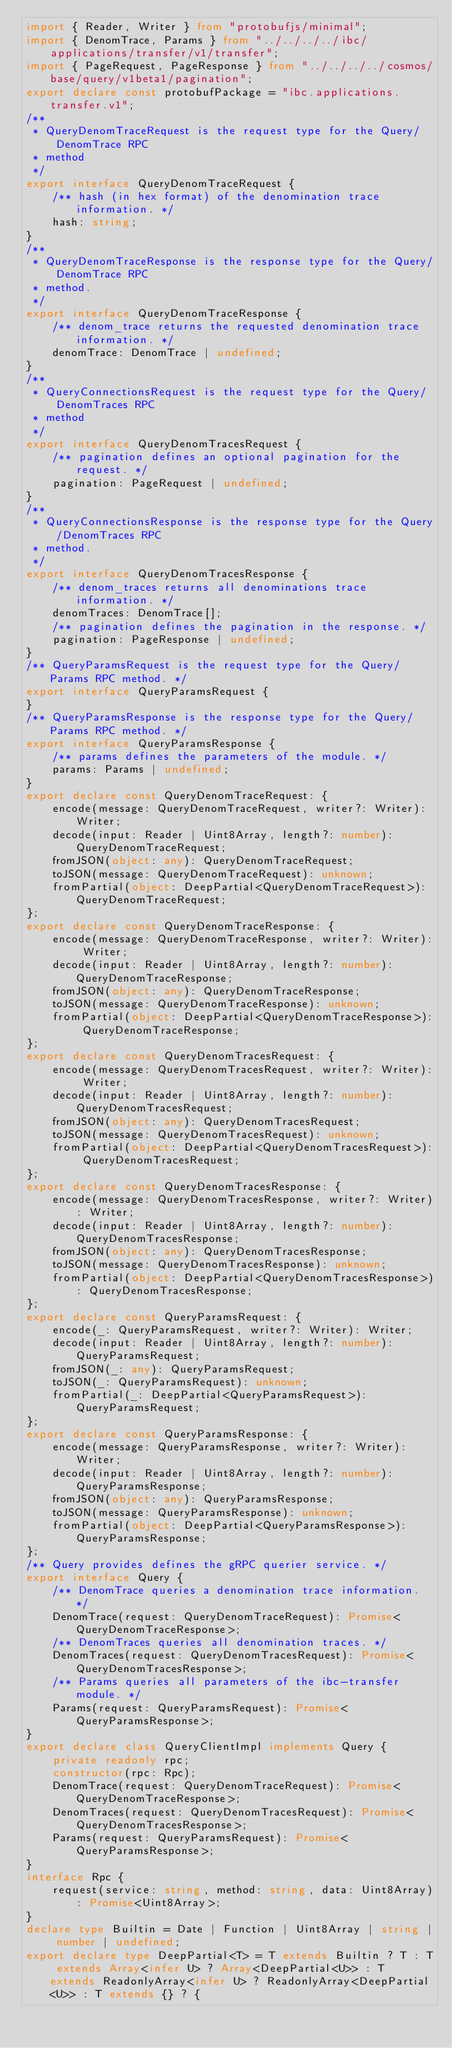<code> <loc_0><loc_0><loc_500><loc_500><_TypeScript_>import { Reader, Writer } from "protobufjs/minimal";
import { DenomTrace, Params } from "../../../../ibc/applications/transfer/v1/transfer";
import { PageRequest, PageResponse } from "../../../../cosmos/base/query/v1beta1/pagination";
export declare const protobufPackage = "ibc.applications.transfer.v1";
/**
 * QueryDenomTraceRequest is the request type for the Query/DenomTrace RPC
 * method
 */
export interface QueryDenomTraceRequest {
    /** hash (in hex format) of the denomination trace information. */
    hash: string;
}
/**
 * QueryDenomTraceResponse is the response type for the Query/DenomTrace RPC
 * method.
 */
export interface QueryDenomTraceResponse {
    /** denom_trace returns the requested denomination trace information. */
    denomTrace: DenomTrace | undefined;
}
/**
 * QueryConnectionsRequest is the request type for the Query/DenomTraces RPC
 * method
 */
export interface QueryDenomTracesRequest {
    /** pagination defines an optional pagination for the request. */
    pagination: PageRequest | undefined;
}
/**
 * QueryConnectionsResponse is the response type for the Query/DenomTraces RPC
 * method.
 */
export interface QueryDenomTracesResponse {
    /** denom_traces returns all denominations trace information. */
    denomTraces: DenomTrace[];
    /** pagination defines the pagination in the response. */
    pagination: PageResponse | undefined;
}
/** QueryParamsRequest is the request type for the Query/Params RPC method. */
export interface QueryParamsRequest {
}
/** QueryParamsResponse is the response type for the Query/Params RPC method. */
export interface QueryParamsResponse {
    /** params defines the parameters of the module. */
    params: Params | undefined;
}
export declare const QueryDenomTraceRequest: {
    encode(message: QueryDenomTraceRequest, writer?: Writer): Writer;
    decode(input: Reader | Uint8Array, length?: number): QueryDenomTraceRequest;
    fromJSON(object: any): QueryDenomTraceRequest;
    toJSON(message: QueryDenomTraceRequest): unknown;
    fromPartial(object: DeepPartial<QueryDenomTraceRequest>): QueryDenomTraceRequest;
};
export declare const QueryDenomTraceResponse: {
    encode(message: QueryDenomTraceResponse, writer?: Writer): Writer;
    decode(input: Reader | Uint8Array, length?: number): QueryDenomTraceResponse;
    fromJSON(object: any): QueryDenomTraceResponse;
    toJSON(message: QueryDenomTraceResponse): unknown;
    fromPartial(object: DeepPartial<QueryDenomTraceResponse>): QueryDenomTraceResponse;
};
export declare const QueryDenomTracesRequest: {
    encode(message: QueryDenomTracesRequest, writer?: Writer): Writer;
    decode(input: Reader | Uint8Array, length?: number): QueryDenomTracesRequest;
    fromJSON(object: any): QueryDenomTracesRequest;
    toJSON(message: QueryDenomTracesRequest): unknown;
    fromPartial(object: DeepPartial<QueryDenomTracesRequest>): QueryDenomTracesRequest;
};
export declare const QueryDenomTracesResponse: {
    encode(message: QueryDenomTracesResponse, writer?: Writer): Writer;
    decode(input: Reader | Uint8Array, length?: number): QueryDenomTracesResponse;
    fromJSON(object: any): QueryDenomTracesResponse;
    toJSON(message: QueryDenomTracesResponse): unknown;
    fromPartial(object: DeepPartial<QueryDenomTracesResponse>): QueryDenomTracesResponse;
};
export declare const QueryParamsRequest: {
    encode(_: QueryParamsRequest, writer?: Writer): Writer;
    decode(input: Reader | Uint8Array, length?: number): QueryParamsRequest;
    fromJSON(_: any): QueryParamsRequest;
    toJSON(_: QueryParamsRequest): unknown;
    fromPartial(_: DeepPartial<QueryParamsRequest>): QueryParamsRequest;
};
export declare const QueryParamsResponse: {
    encode(message: QueryParamsResponse, writer?: Writer): Writer;
    decode(input: Reader | Uint8Array, length?: number): QueryParamsResponse;
    fromJSON(object: any): QueryParamsResponse;
    toJSON(message: QueryParamsResponse): unknown;
    fromPartial(object: DeepPartial<QueryParamsResponse>): QueryParamsResponse;
};
/** Query provides defines the gRPC querier service. */
export interface Query {
    /** DenomTrace queries a denomination trace information. */
    DenomTrace(request: QueryDenomTraceRequest): Promise<QueryDenomTraceResponse>;
    /** DenomTraces queries all denomination traces. */
    DenomTraces(request: QueryDenomTracesRequest): Promise<QueryDenomTracesResponse>;
    /** Params queries all parameters of the ibc-transfer module. */
    Params(request: QueryParamsRequest): Promise<QueryParamsResponse>;
}
export declare class QueryClientImpl implements Query {
    private readonly rpc;
    constructor(rpc: Rpc);
    DenomTrace(request: QueryDenomTraceRequest): Promise<QueryDenomTraceResponse>;
    DenomTraces(request: QueryDenomTracesRequest): Promise<QueryDenomTracesResponse>;
    Params(request: QueryParamsRequest): Promise<QueryParamsResponse>;
}
interface Rpc {
    request(service: string, method: string, data: Uint8Array): Promise<Uint8Array>;
}
declare type Builtin = Date | Function | Uint8Array | string | number | undefined;
export declare type DeepPartial<T> = T extends Builtin ? T : T extends Array<infer U> ? Array<DeepPartial<U>> : T extends ReadonlyArray<infer U> ? ReadonlyArray<DeepPartial<U>> : T extends {} ? {</code> 